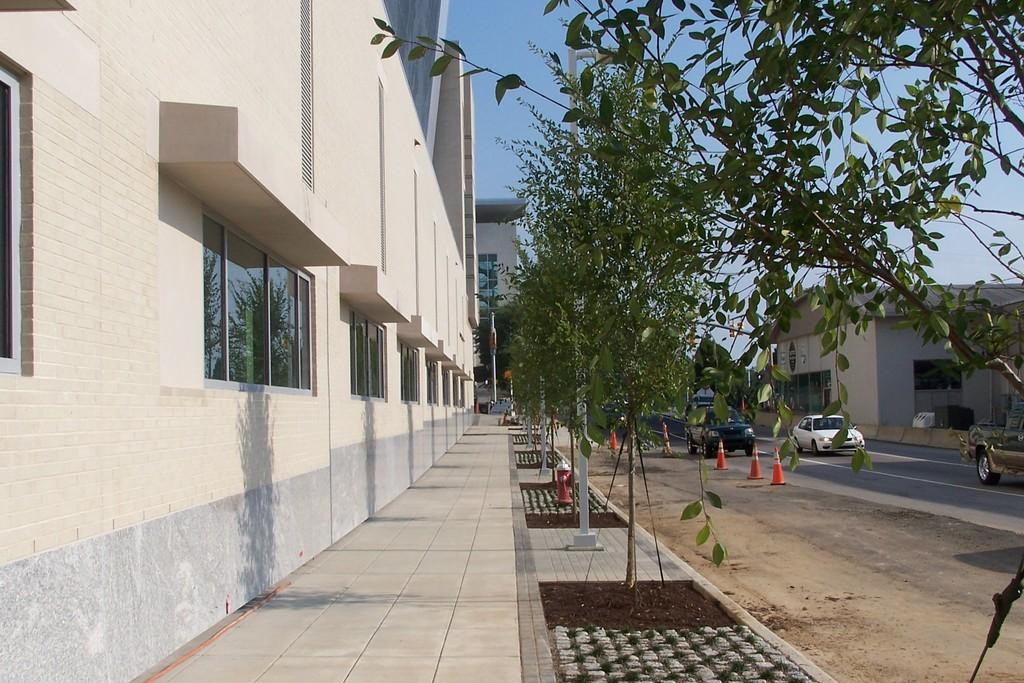What type of structures can be seen in the image? There are buildings with windows in the image. What else is present in the image besides buildings? There are plants, cables, traffic poles, vehicles on the road, and poles visible in the image. How would you describe the sky in the image? The sky is visible in the image, and it appears cloudy. Can you tell me how many basketballs are being played with in the image? There are no basketballs or basketball games present in the image. What is the current state of the people's minds in the image? There is no information about the people's minds or mental states in the image. 